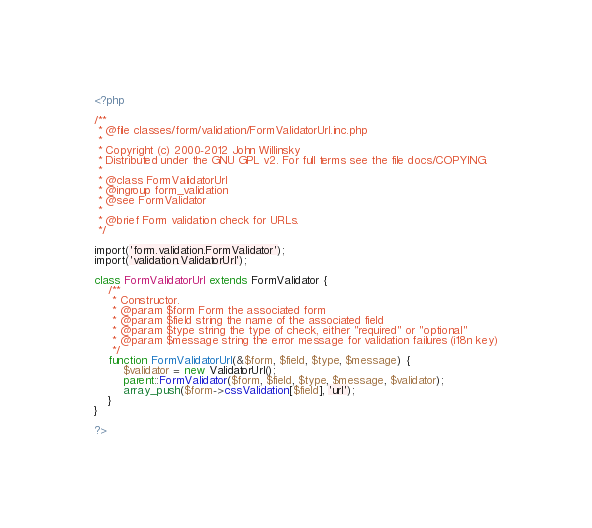Convert code to text. <code><loc_0><loc_0><loc_500><loc_500><_PHP_><?php

/**
 * @file classes/form/validation/FormValidatorUrl.inc.php
 *
 * Copyright (c) 2000-2012 John Willinsky
 * Distributed under the GNU GPL v2. For full terms see the file docs/COPYING.
 *
 * @class FormValidatorUrl
 * @ingroup form_validation
 * @see FormValidator
 *
 * @brief Form validation check for URLs.
 */

import('form.validation.FormValidator');
import('validation.ValidatorUrl');

class FormValidatorUrl extends FormValidator {
	/**
	 * Constructor.
	 * @param $form Form the associated form
	 * @param $field string the name of the associated field
	 * @param $type string the type of check, either "required" or "optional"
	 * @param $message string the error message for validation failures (i18n key)
	 */
	function FormValidatorUrl(&$form, $field, $type, $message) {
		$validator = new ValidatorUrl();
		parent::FormValidator($form, $field, $type, $message, $validator);
		array_push($form->cssValidation[$field], 'url');
	}
}

?>
</code> 